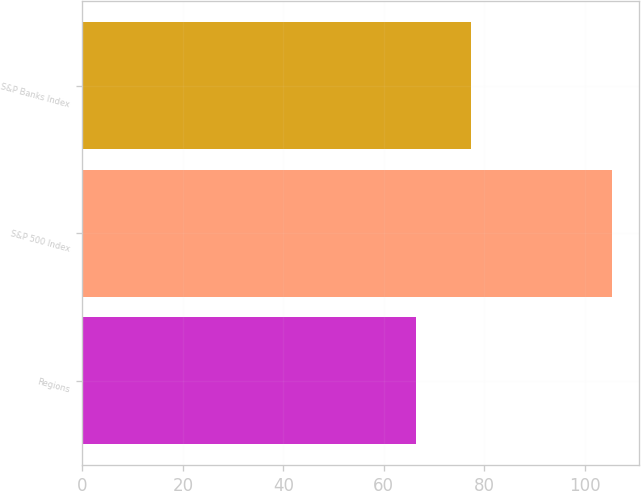Convert chart. <chart><loc_0><loc_0><loc_500><loc_500><bar_chart><fcel>Regions<fcel>S&P 500 Index<fcel>S&P Banks Index<nl><fcel>66.36<fcel>105.49<fcel>77.32<nl></chart> 